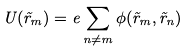Convert formula to latex. <formula><loc_0><loc_0><loc_500><loc_500>U ( \vec { r } _ { m } ) = e \sum _ { n \neq m } \phi ( \vec { r } _ { m } , \vec { r } _ { n } )</formula> 